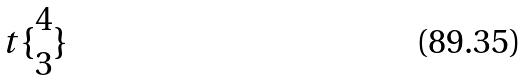<formula> <loc_0><loc_0><loc_500><loc_500>t \{ \begin{matrix} 4 \\ 3 \end{matrix} \}</formula> 